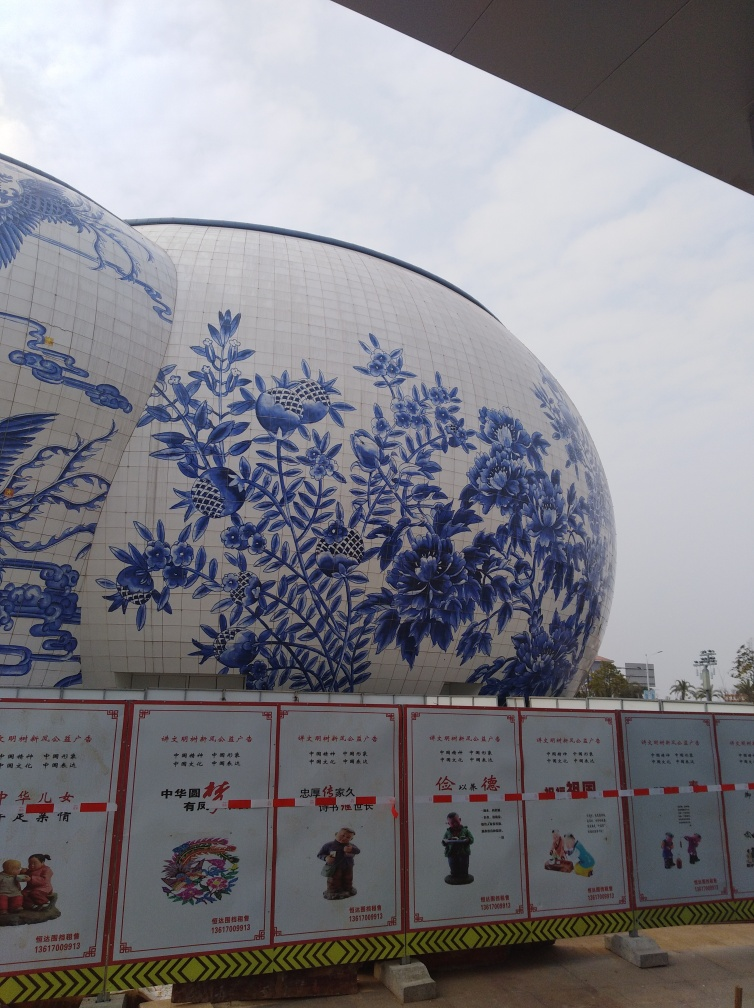Can you tell me more about the artwork on the building's surface? Certainly! The artwork on the building appears to be a large-scale representation of classic Chinese porcelain patterns, particularly those that arose during the Ming dynasty. It features an assortment of botanical elements, such as flowers and leaves, as well as depictions of birds, which are common motifs in Chinese artistry. 